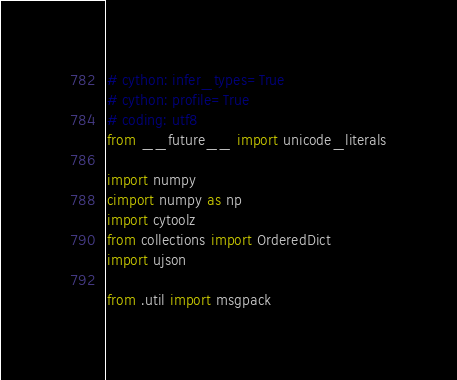Convert code to text. <code><loc_0><loc_0><loc_500><loc_500><_Cython_># cython: infer_types=True
# cython: profile=True
# coding: utf8
from __future__ import unicode_literals

import numpy
cimport numpy as np
import cytoolz
from collections import OrderedDict
import ujson

from .util import msgpack</code> 